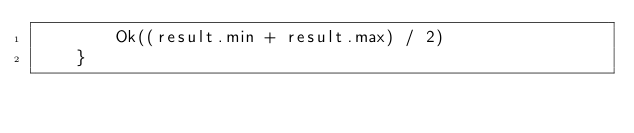<code> <loc_0><loc_0><loc_500><loc_500><_Rust_>        Ok((result.min + result.max) / 2)
    }
</code> 